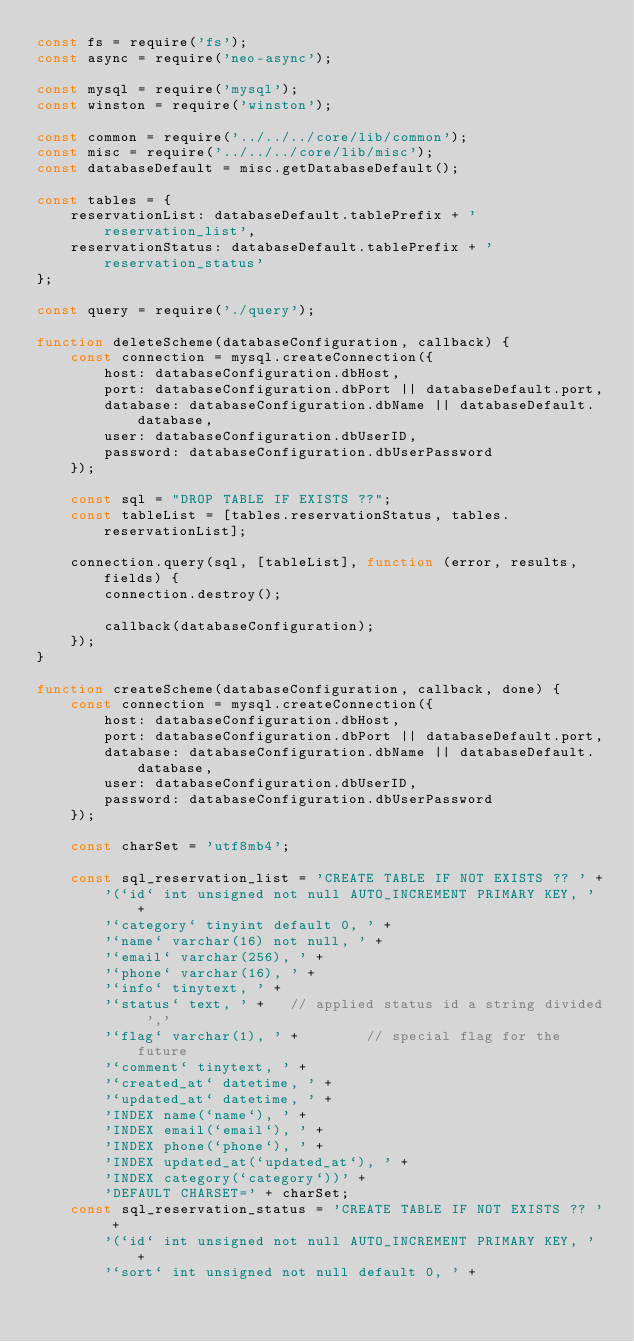Convert code to text. <code><loc_0><loc_0><loc_500><loc_500><_JavaScript_>const fs = require('fs');
const async = require('neo-async');

const mysql = require('mysql');
const winston = require('winston');

const common = require('../../../core/lib/common');
const misc = require('../../../core/lib/misc');
const databaseDefault = misc.getDatabaseDefault();

const tables = {
    reservationList: databaseDefault.tablePrefix + 'reservation_list',
    reservationStatus: databaseDefault.tablePrefix + 'reservation_status'
};

const query = require('./query');

function deleteScheme(databaseConfiguration, callback) {
    const connection = mysql.createConnection({
        host: databaseConfiguration.dbHost,
        port: databaseConfiguration.dbPort || databaseDefault.port,
        database: databaseConfiguration.dbName || databaseDefault.database,
        user: databaseConfiguration.dbUserID,
        password: databaseConfiguration.dbUserPassword
    });

    const sql = "DROP TABLE IF EXISTS ??";
    const tableList = [tables.reservationStatus, tables.reservationList];

    connection.query(sql, [tableList], function (error, results, fields) {
        connection.destroy();

        callback(databaseConfiguration);
    });
}

function createScheme(databaseConfiguration, callback, done) {
    const connection = mysql.createConnection({
        host: databaseConfiguration.dbHost,
        port: databaseConfiguration.dbPort || databaseDefault.port,
        database: databaseConfiguration.dbName || databaseDefault.database,
        user: databaseConfiguration.dbUserID,
        password: databaseConfiguration.dbUserPassword
    });

    const charSet = 'utf8mb4';

    const sql_reservation_list = 'CREATE TABLE IF NOT EXISTS ?? ' +
        '(`id` int unsigned not null AUTO_INCREMENT PRIMARY KEY, ' +
        '`category` tinyint default 0, ' +
        '`name` varchar(16) not null, ' +
        '`email` varchar(256), ' +
        '`phone` varchar(16), ' +
        '`info` tinytext, ' +
        '`status` text, ' +   // applied status id a string divided ','
        '`flag` varchar(1), ' +        // special flag for the future
        '`comment` tinytext, ' +
        '`created_at` datetime, ' +
        '`updated_at` datetime, ' +
        'INDEX name(`name`), ' +
        'INDEX email(`email`), ' +
        'INDEX phone(`phone`), ' +
        'INDEX updated_at(`updated_at`), ' +
        'INDEX category(`category`))' +
        'DEFAULT CHARSET=' + charSet;
    const sql_reservation_status = 'CREATE TABLE IF NOT EXISTS ?? ' +
        '(`id` int unsigned not null AUTO_INCREMENT PRIMARY KEY, ' +
        '`sort` int unsigned not null default 0, ' +</code> 